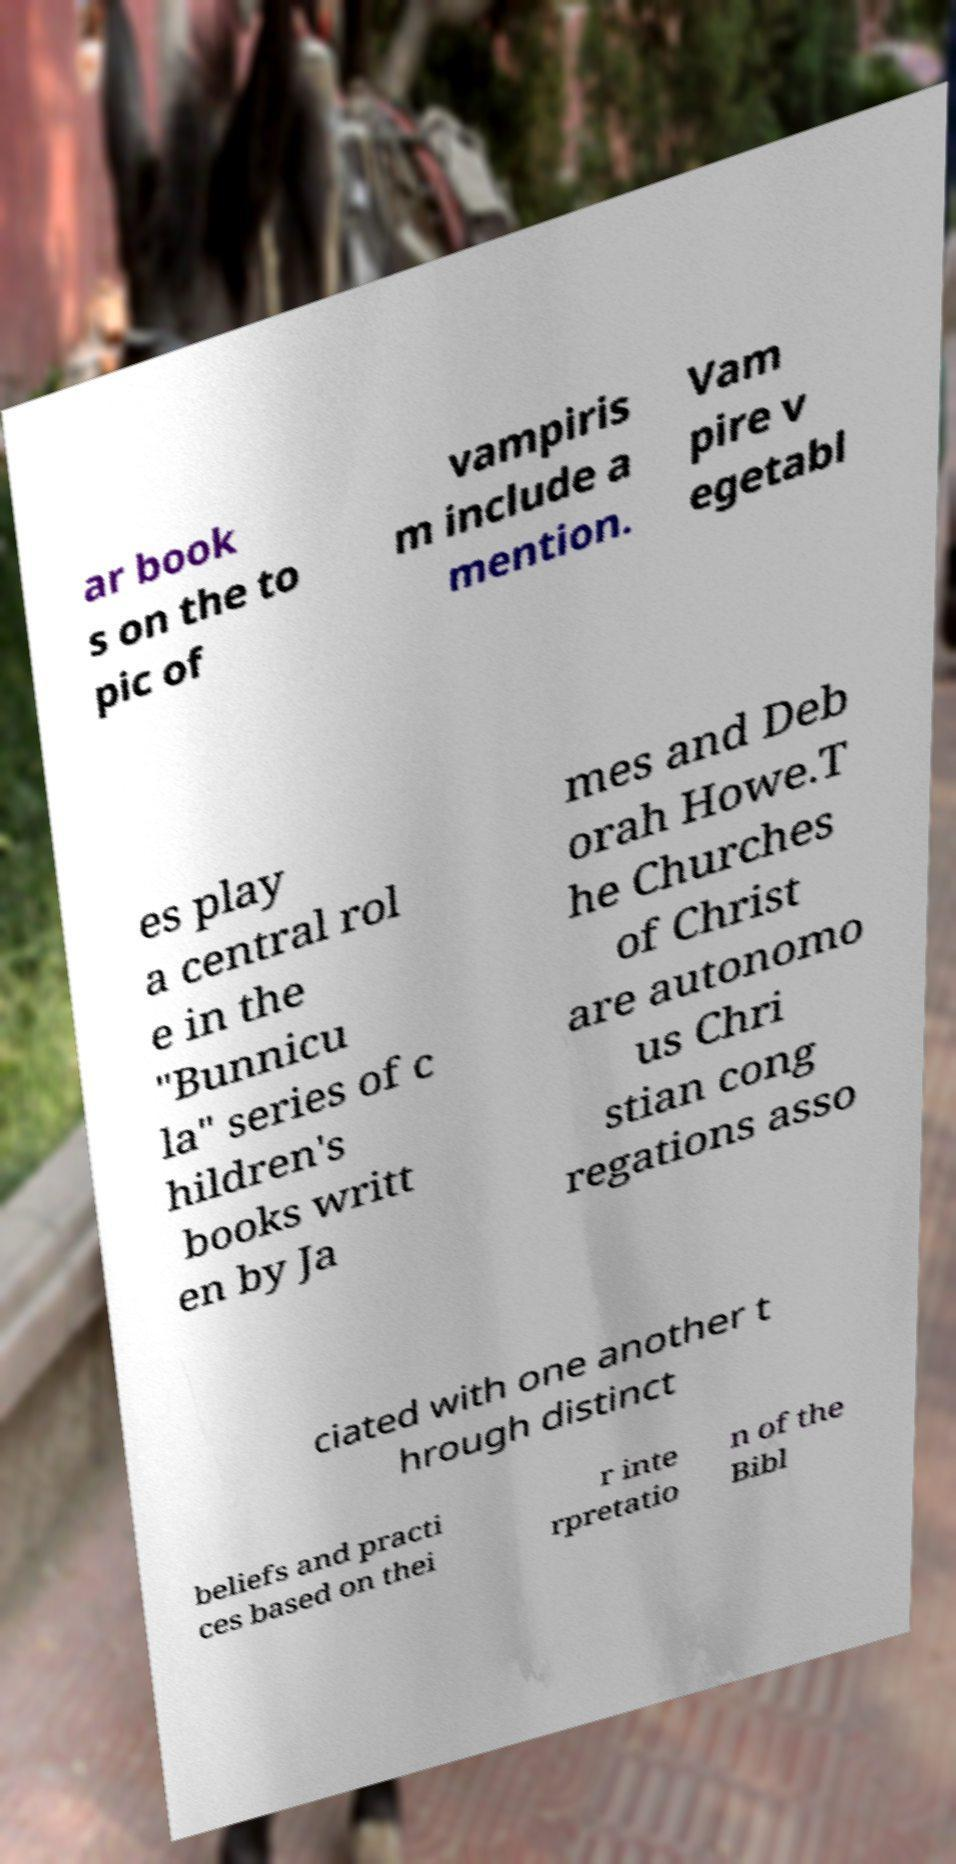Could you assist in decoding the text presented in this image and type it out clearly? ar book s on the to pic of vampiris m include a mention. Vam pire v egetabl es play a central rol e in the "Bunnicu la" series of c hildren's books writt en by Ja mes and Deb orah Howe.T he Churches of Christ are autonomo us Chri stian cong regations asso ciated with one another t hrough distinct beliefs and practi ces based on thei r inte rpretatio n of the Bibl 